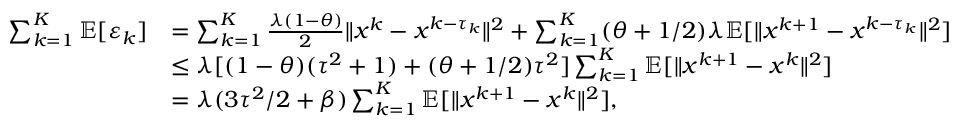Convert formula to latex. <formula><loc_0><loc_0><loc_500><loc_500>\begin{array} { r l } { \sum _ { k = 1 } ^ { K } \mathbb { E } [ \varepsilon _ { k } ] } & { = \sum _ { k = 1 } ^ { K } \frac { \lambda ( 1 - \theta ) } { 2 } \| x ^ { k } - x ^ { k - \tau _ { k } } \| ^ { 2 } + \sum _ { k = 1 } ^ { K } ( \theta + 1 / 2 ) \lambda \mathbb { E } [ \| x ^ { k + 1 } - x ^ { k - \tau _ { k } } \| ^ { 2 } ] } \\ & { \leq \lambda [ ( 1 - \theta ) ( \tau ^ { 2 } + 1 ) + ( \theta + 1 / 2 ) \tau ^ { 2 } ] \sum _ { k = 1 } ^ { K } \mathbb { E } [ \| x ^ { k + 1 } - x ^ { k } \| ^ { 2 } ] } \\ & { = \lambda ( 3 \tau ^ { 2 } / 2 + \beta ) \sum _ { k = 1 } ^ { K } \mathbb { E } [ \| x ^ { k + 1 } - x ^ { k } \| ^ { 2 } ] , } \end{array}</formula> 